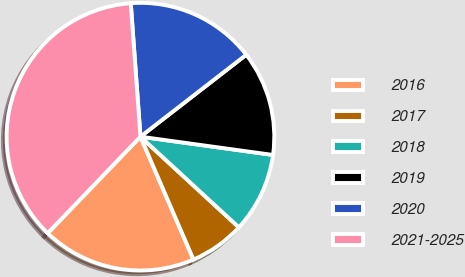Convert chart. <chart><loc_0><loc_0><loc_500><loc_500><pie_chart><fcel>2016<fcel>2017<fcel>2018<fcel>2019<fcel>2020<fcel>2021-2025<nl><fcel>18.67%<fcel>6.67%<fcel>9.67%<fcel>12.67%<fcel>15.67%<fcel>36.67%<nl></chart> 